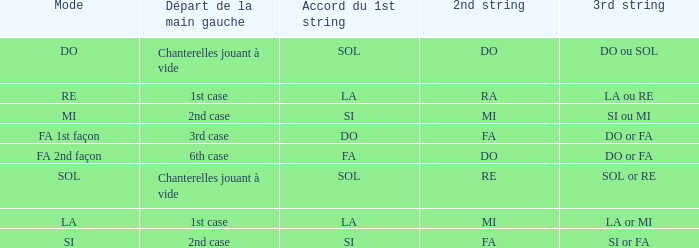Could you parse the entire table? {'header': ['Mode', 'Départ de la main gauche', 'Accord du 1st string', '2nd string', '3rd string'], 'rows': [['DO', 'Chanterelles jouant à vide', 'SOL', 'DO', 'DO ou SOL'], ['RE', '1st case', 'LA', 'RA', 'LA ou RE'], ['MI', '2nd case', 'SI', 'MI', 'SI ou MI'], ['FA 1st façon', '3rd case', 'DO', 'FA', 'DO or FA'], ['FA 2nd façon', '6th case', 'FA', 'DO', 'DO or FA'], ['SOL', 'Chanterelles jouant à vide', 'SOL', 'RE', 'SOL or RE'], ['LA', '1st case', 'LA', 'MI', 'LA or MI'], ['SI', '2nd case', 'SI', 'FA', 'SI or FA']]} Given that the 1st string is si accord du and the 2nd string is mi, what can be identified as the 3rd string? SI ou MI. 